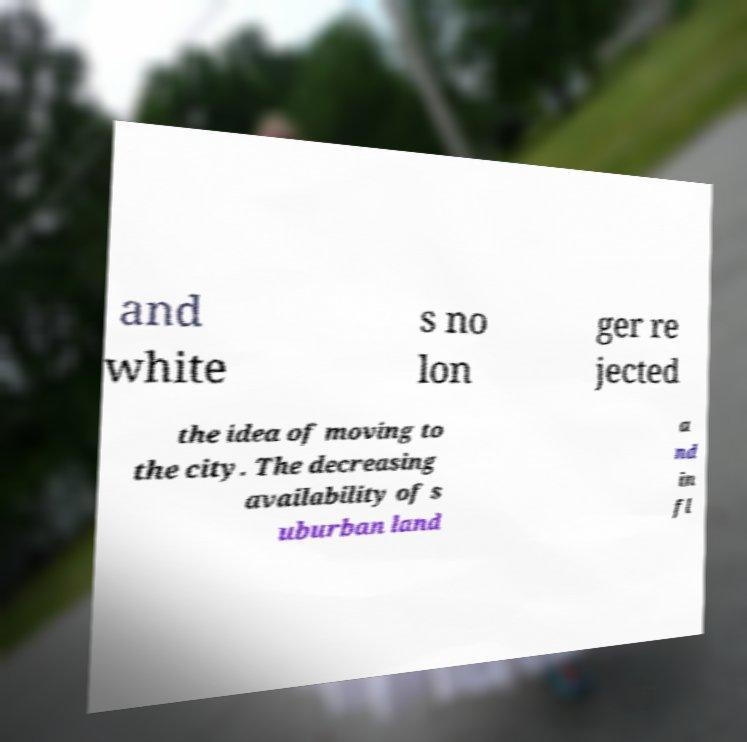For documentation purposes, I need the text within this image transcribed. Could you provide that? and white s no lon ger re jected the idea of moving to the city. The decreasing availability of s uburban land a nd in fl 